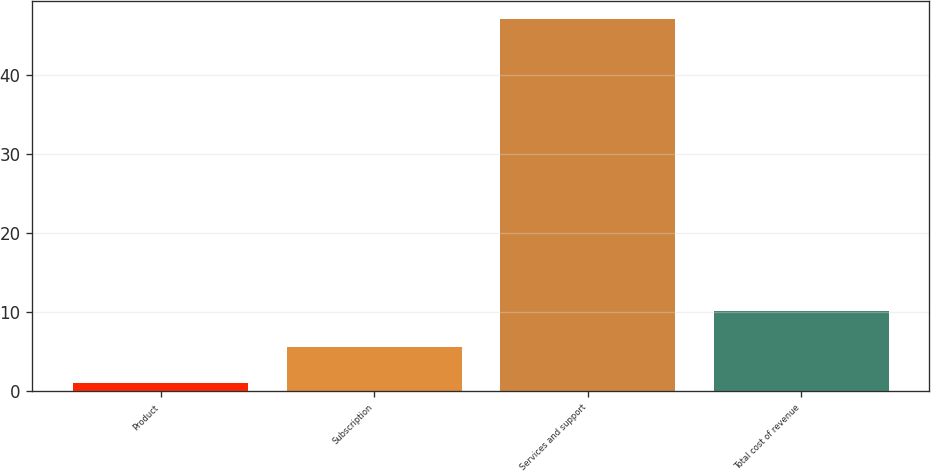Convert chart. <chart><loc_0><loc_0><loc_500><loc_500><bar_chart><fcel>Product<fcel>Subscription<fcel>Services and support<fcel>Total cost of revenue<nl><fcel>1<fcel>5.6<fcel>47<fcel>10.2<nl></chart> 